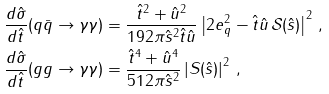<formula> <loc_0><loc_0><loc_500><loc_500>\frac { d \hat { \sigma } } { d \hat { t } } ( q \bar { q } \rightarrow \gamma \gamma ) & = \frac { \hat { t } ^ { 2 } + \hat { u } ^ { 2 } } { 1 9 2 \pi \hat { s } ^ { 2 } \hat { t } \hat { u } } \left | 2 e _ { q } ^ { 2 } - \hat { t } \hat { u } \, \mathcal { S } ( \hat { s } ) \right | ^ { 2 } \, , \\ \frac { d \hat { \sigma } } { d \hat { t } } ( g g \rightarrow \gamma \gamma ) & = \frac { \hat { t } ^ { 4 } + \hat { u } ^ { 4 } } { 5 1 2 \pi \hat { s } ^ { 2 } } \left | { S } ( \hat { s } ) \right | ^ { 2 } \, ,</formula> 